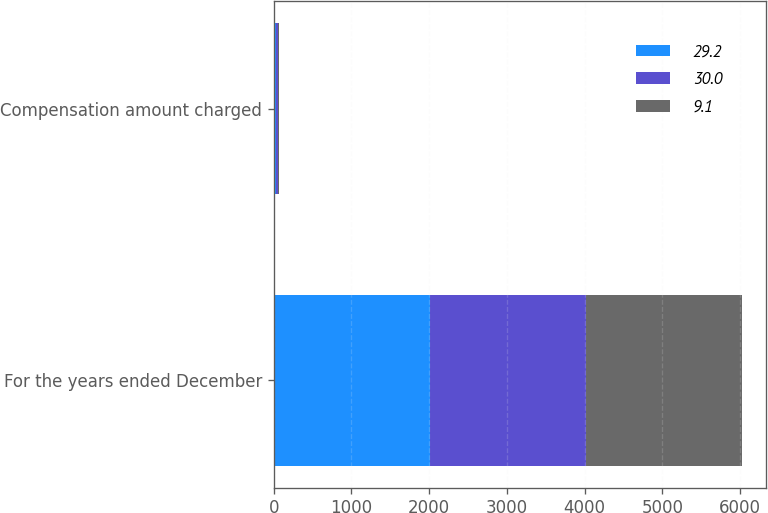Convert chart to OTSL. <chart><loc_0><loc_0><loc_500><loc_500><stacked_bar_chart><ecel><fcel>For the years ended December<fcel>Compensation amount charged<nl><fcel>29.2<fcel>2010<fcel>29.2<nl><fcel>30<fcel>2009<fcel>30<nl><fcel>9.1<fcel>2008<fcel>9.1<nl></chart> 